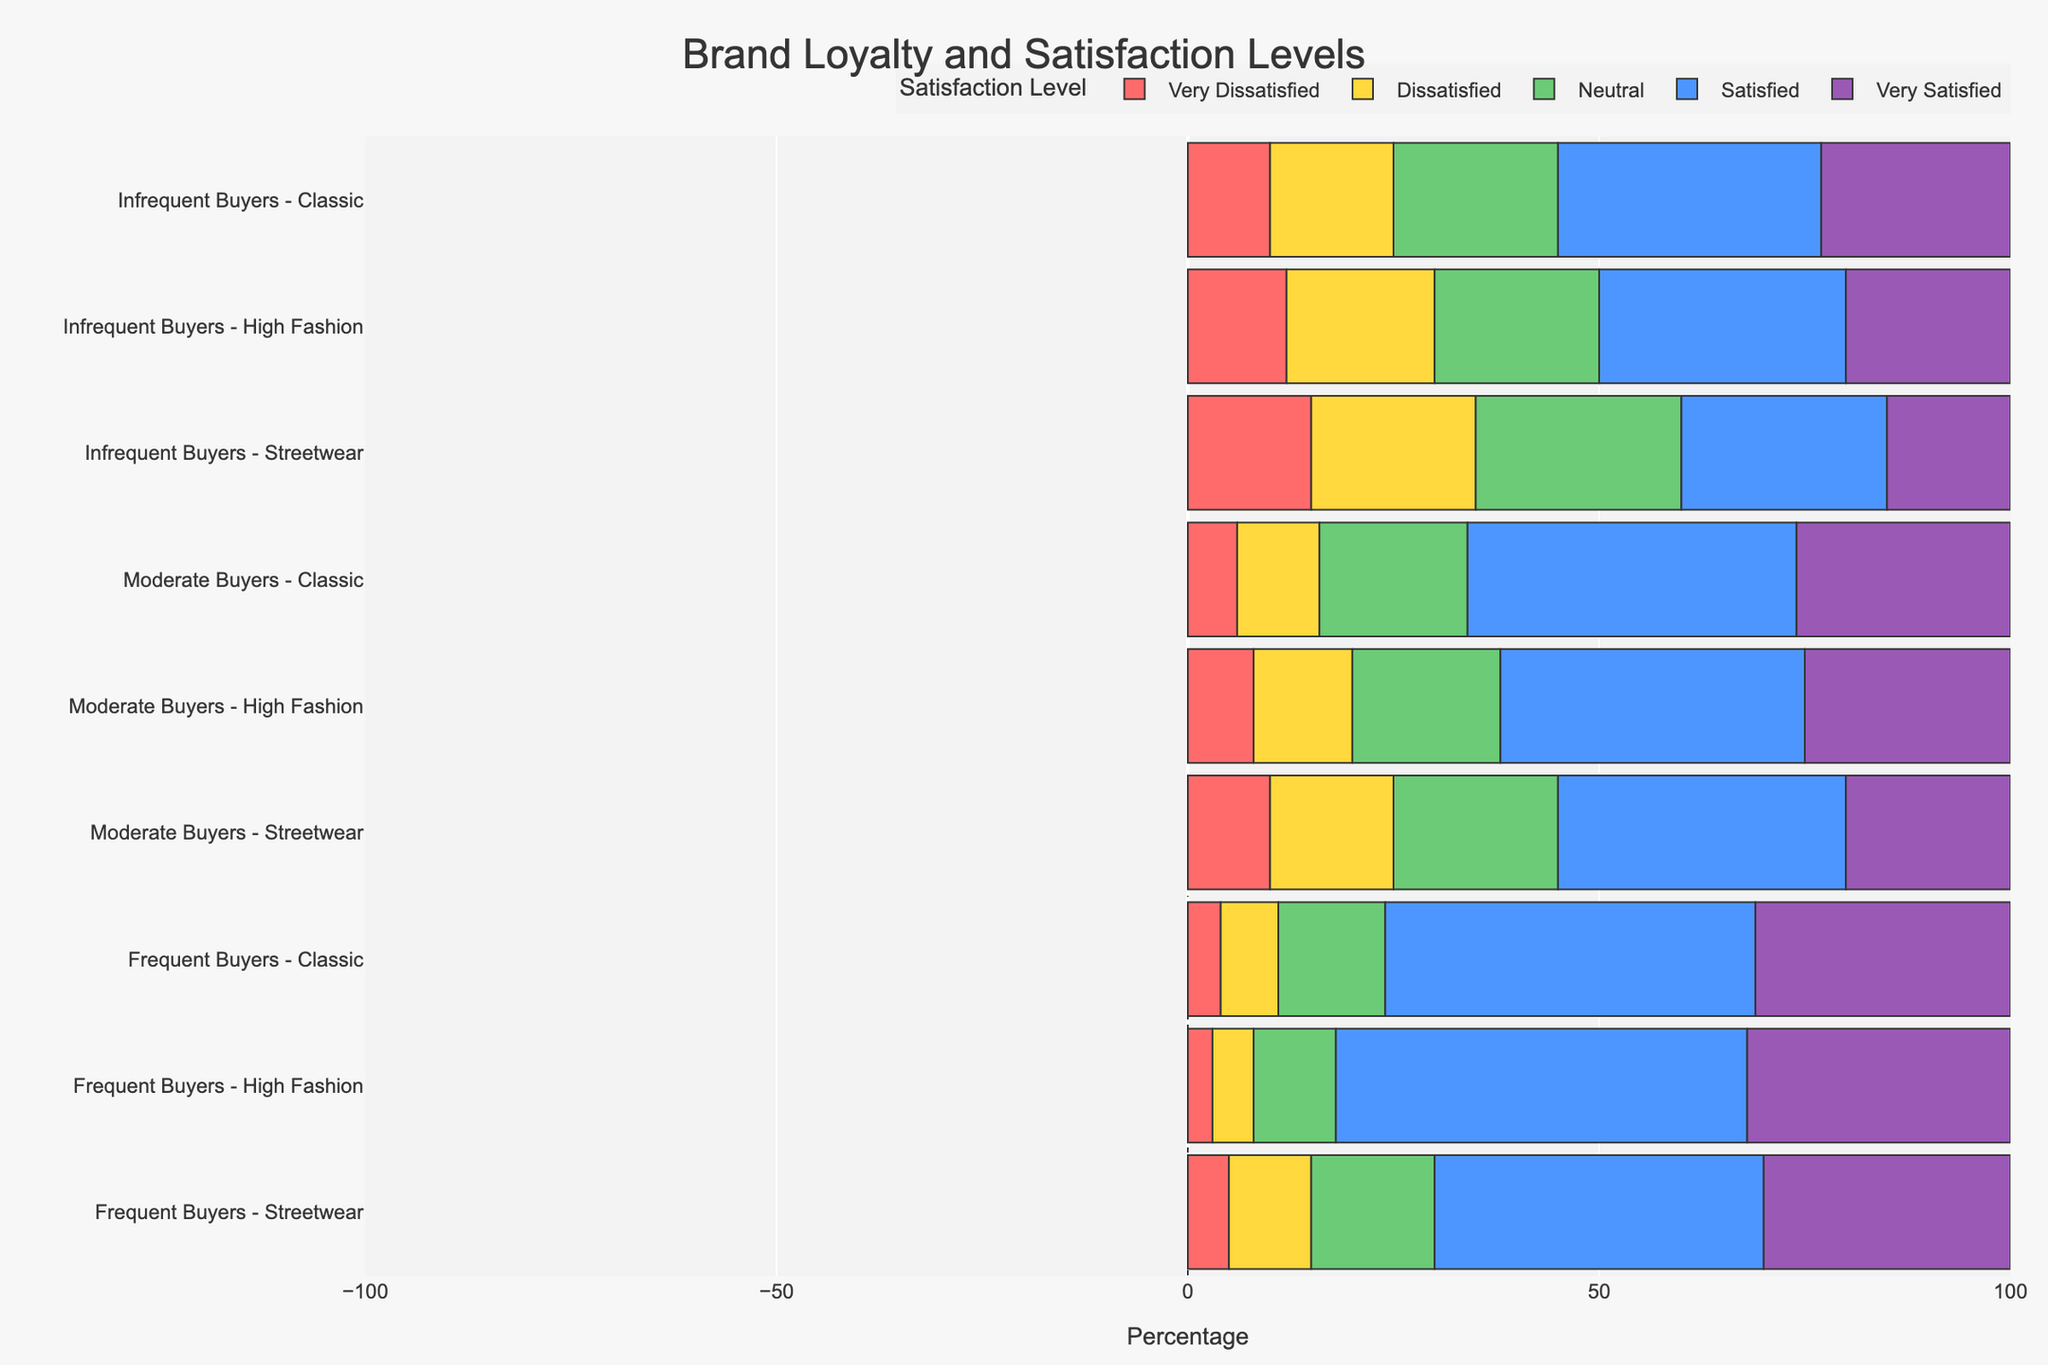What is the total percentage of 'Very Satisfied' customers among 'Frequent Buyers' who prefer 'Streetwear'? First, find the 'Very Satisfied' percentage for 'Frequent Buyers' who prefer 'Streetwear', which is 30%. Since the percentages are already given directly, no further calculation is required.
Answer: 30% How does the percentage of 'Neutral' customers compare between 'Frequent Buyers' of 'High Fashion' and 'Classic' style? The 'Neutral' percentage for 'Frequent Buyers' of 'High Fashion' is 10%, and for 'Classic' style, it is 13%. To compare, observe that 10% is less than 13%.
Answer: 10% is less than 13% Which customer segment and fashion style combination has the highest percentage of 'Satisfied' customers? Check the 'Satisfied' percentages across all combinations. The highest is for 'Frequent Buyers' with 'High Fashion' at 50%.
Answer: Frequent Buyers - High Fashion What is the sum of 'Dissatisfied' and 'Very Dissatisfied' customers for 'Moderate Buyers' who prefer 'Streetwear'? The 'Dissatisfied' percentage is 15% and the 'Very Dissatisfied' percentage is 10%. Summing them gives 15 + 10 = 25%.
Answer: 25% Which group has the longest bar in green representing 'Satisfied' customers? The green bars represent 'Satisfied' customers. The longest bar is for 'Frequent Buyers' in 'High Fashion' with 50%.
Answer: Frequent Buyers - High Fashion Does the percentage of 'Very Dissatisfied' customers increase, decrease, or stay the same as purchase frequency decreases for 'Classic' style? For 'Frequent Buyers' it's 4%, for 'Moderate Buyers' it's 6%, and for 'Infrequent Buyers' it's 10%. The percentage increases as purchase frequency decreases.
Answer: Increases What is the average percentage of 'Satisfied' customers across all 'Moderate Buyers'? The 'Satisfied' percentages for 'Moderate Buyers' are 35% (Streetwear), 37% (High Fashion), and 40% (Classic). The average is (35 + 37 + 40) / 3 = 37.33%.
Answer: 37.33% Compare the percentage of 'Very Satisfied' customers between 'Weekly' and 'Monthly' purchase frequency for 'Streetwear'. 'Weekly' for 'Streetwear' has 30% 'Very Satisfied' and 'Monthly' has 20%. Comparing these, 30% is greater than 20%.
Answer: 30% is greater than 20% Which fashion style among 'Infrequent Buyers' has the least percentage of 'Neutral' customers? The 'Neutral' percentages for 'Infrequent Buyers' are 25% (Streetwear), 20% (High Fashion), and 20% (Classic). Both 'High Fashion' and 'Classic' styles have the least percentage at 20%.
Answer: High Fashion and Classic (tie) 